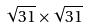Convert formula to latex. <formula><loc_0><loc_0><loc_500><loc_500>\sqrt { 3 1 } \times \sqrt { 3 1 }</formula> 